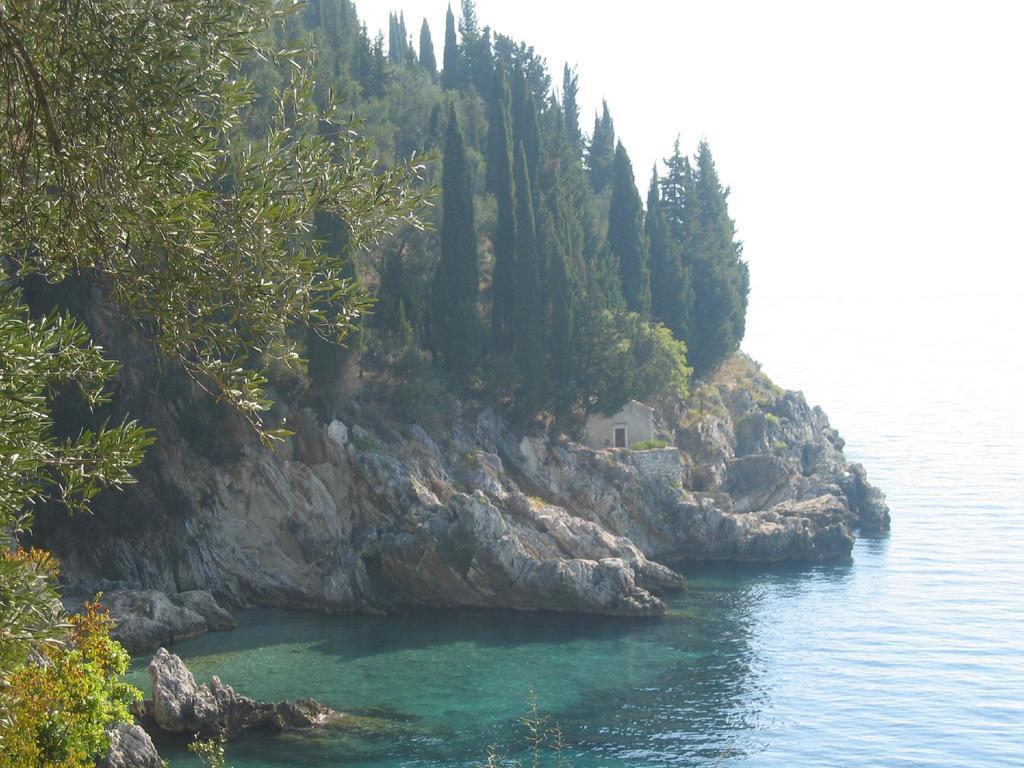Can you describe this image briefly? In the center of the image we can see the sky, trees, water, one house and the hill. 